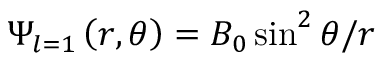Convert formula to latex. <formula><loc_0><loc_0><loc_500><loc_500>\Psi _ { l = 1 } \left ( r , \theta \right ) = B _ { 0 } \sin ^ { 2 } \theta / r</formula> 